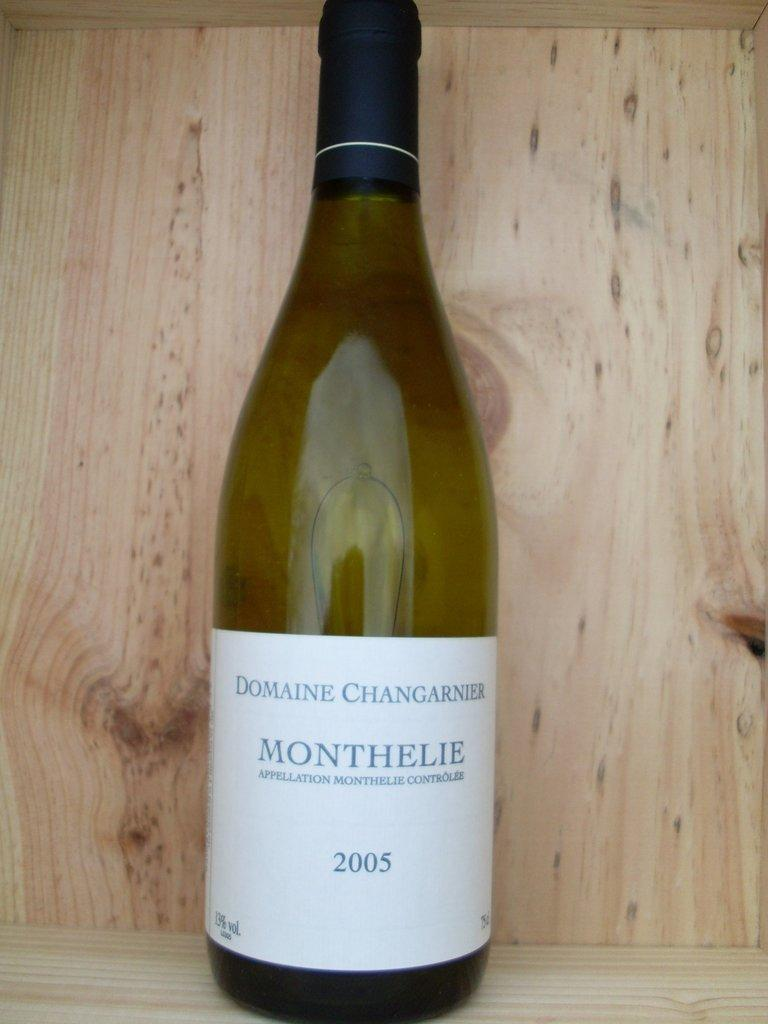What is the main object in the image? There is a wine bottle in the image. Can you provide any additional information about the wine bottle? The wine bottle has the year 2005 written on it. What type of insect can be seen crawling on the wine bottle in the image? There are no insects present in the image; it only features a wine bottle with the year 2005 written on it. 